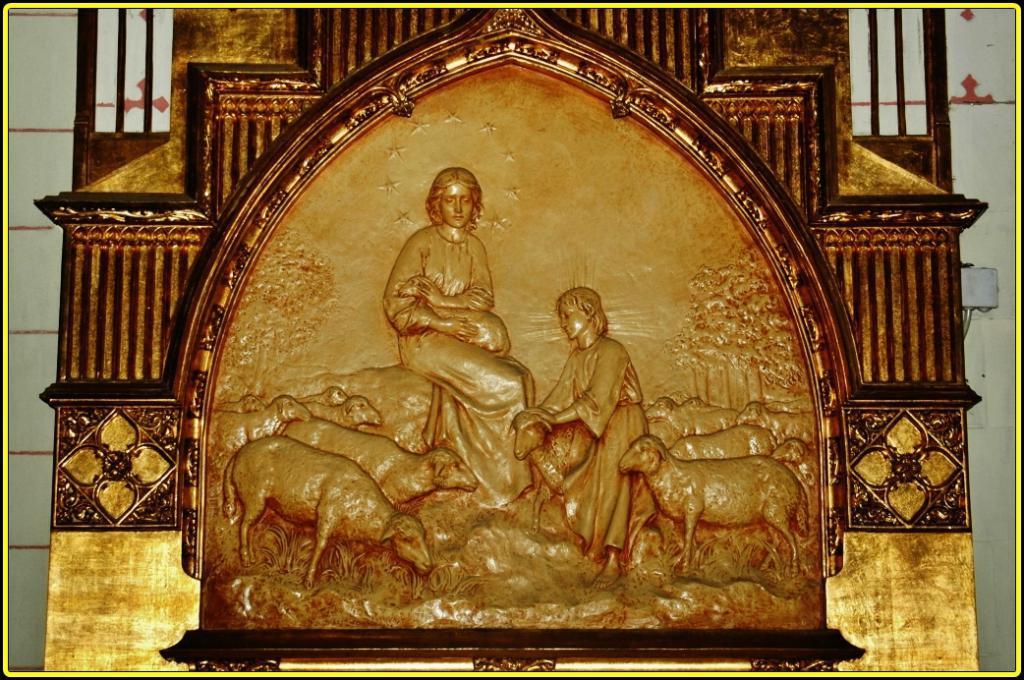Could you give a brief overview of what you see in this image? In the image,there is a sculpture on a wall,there are group of animals around two people in the sculpture. 